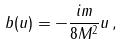<formula> <loc_0><loc_0><loc_500><loc_500>b ( u ) = - \frac { i m } { 8 M ^ { 2 } } u \, ,</formula> 